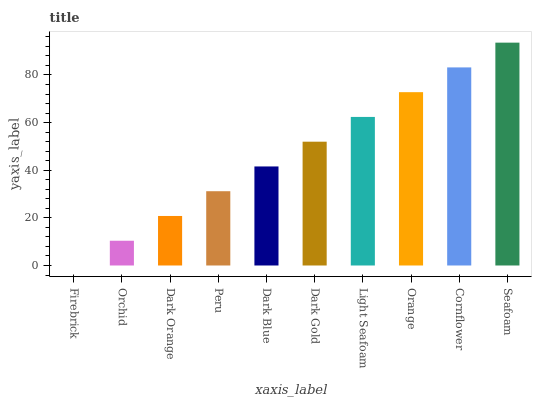Is Firebrick the minimum?
Answer yes or no. Yes. Is Seafoam the maximum?
Answer yes or no. Yes. Is Orchid the minimum?
Answer yes or no. No. Is Orchid the maximum?
Answer yes or no. No. Is Orchid greater than Firebrick?
Answer yes or no. Yes. Is Firebrick less than Orchid?
Answer yes or no. Yes. Is Firebrick greater than Orchid?
Answer yes or no. No. Is Orchid less than Firebrick?
Answer yes or no. No. Is Dark Gold the high median?
Answer yes or no. Yes. Is Dark Blue the low median?
Answer yes or no. Yes. Is Orchid the high median?
Answer yes or no. No. Is Light Seafoam the low median?
Answer yes or no. No. 